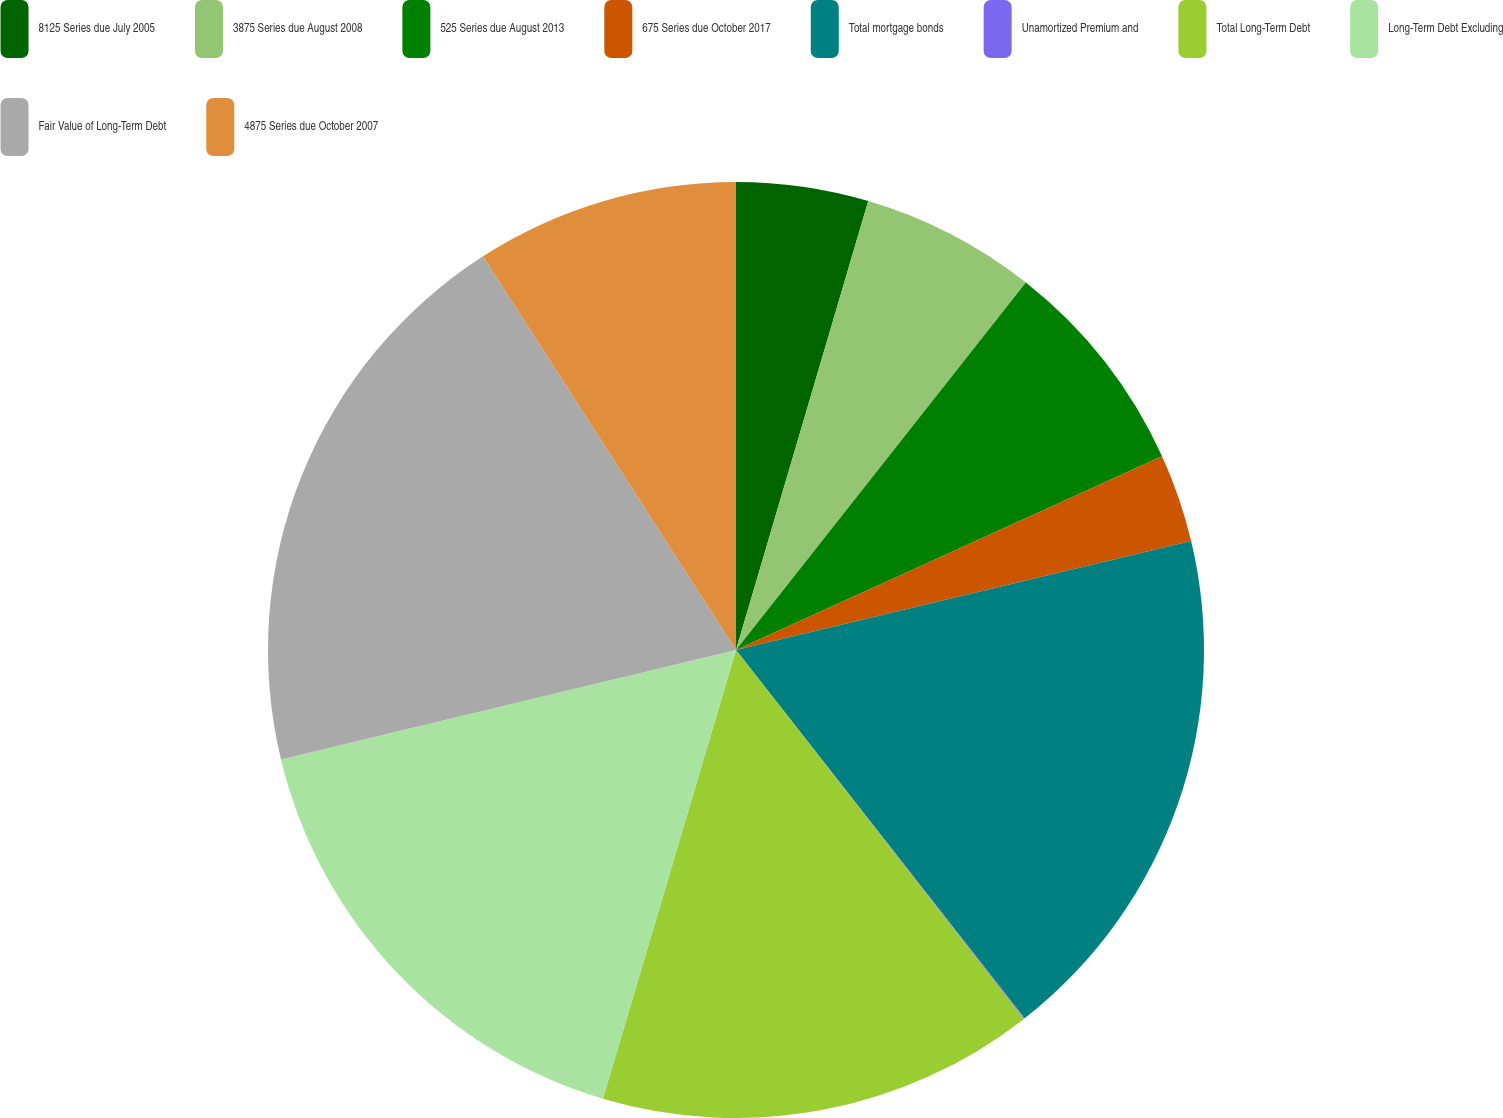<chart> <loc_0><loc_0><loc_500><loc_500><pie_chart><fcel>8125 Series due July 2005<fcel>3875 Series due August 2008<fcel>525 Series due August 2013<fcel>675 Series due October 2017<fcel>Total mortgage bonds<fcel>Unamortized Premium and<fcel>Total Long-Term Debt<fcel>Long-Term Debt Excluding<fcel>Fair Value of Long-Term Debt<fcel>4875 Series due October 2007<nl><fcel>4.56%<fcel>6.07%<fcel>7.58%<fcel>3.05%<fcel>18.16%<fcel>0.03%<fcel>15.14%<fcel>16.65%<fcel>19.67%<fcel>9.09%<nl></chart> 